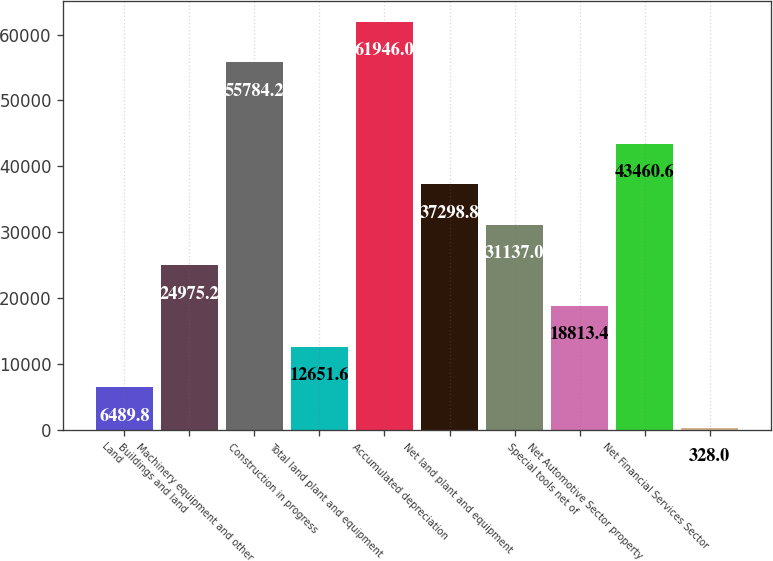Convert chart. <chart><loc_0><loc_0><loc_500><loc_500><bar_chart><fcel>Land<fcel>Buildings and land<fcel>Machinery equipment and other<fcel>Construction in progress<fcel>Total land plant and equipment<fcel>Accumulated depreciation<fcel>Net land plant and equipment<fcel>Special tools net of<fcel>Net Automotive Sector property<fcel>Net Financial Services Sector<nl><fcel>6489.8<fcel>24975.2<fcel>55784.2<fcel>12651.6<fcel>61946<fcel>37298.8<fcel>31137<fcel>18813.4<fcel>43460.6<fcel>328<nl></chart> 